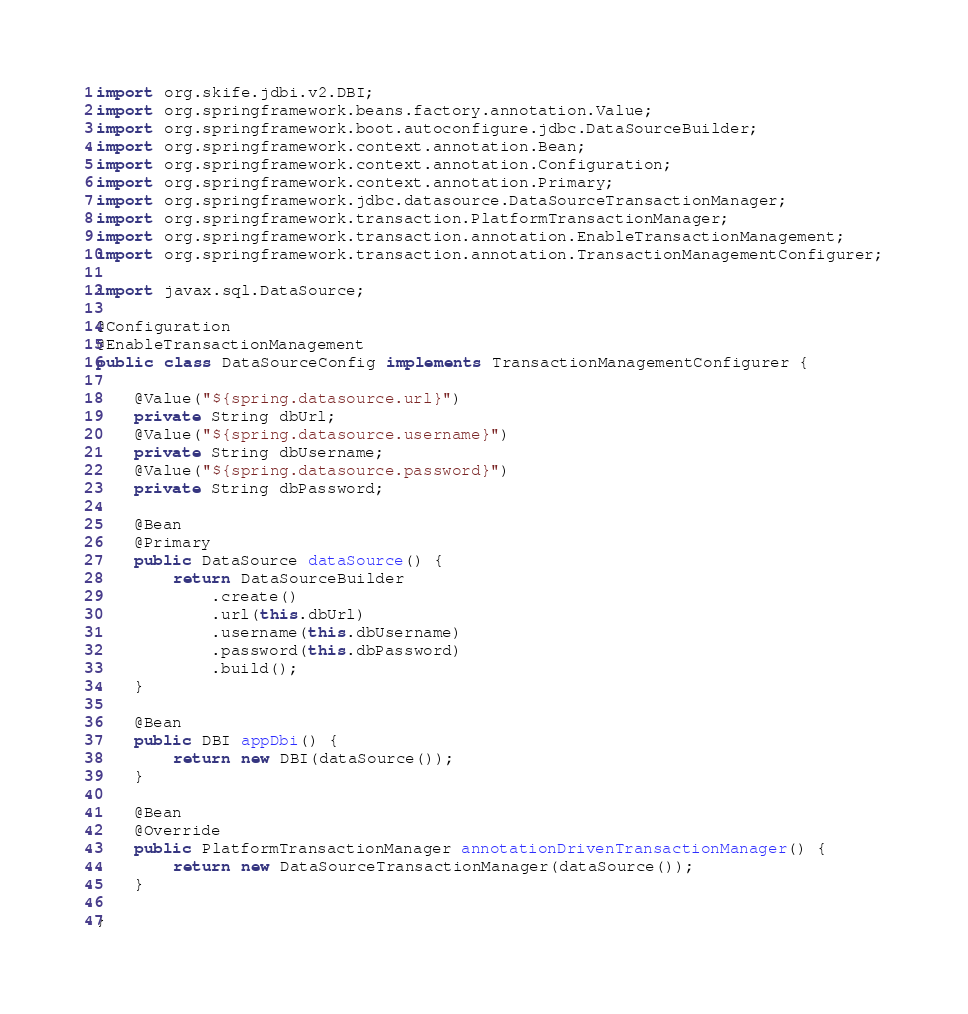<code> <loc_0><loc_0><loc_500><loc_500><_Java_>
import org.skife.jdbi.v2.DBI;
import org.springframework.beans.factory.annotation.Value;
import org.springframework.boot.autoconfigure.jdbc.DataSourceBuilder;
import org.springframework.context.annotation.Bean;
import org.springframework.context.annotation.Configuration;
import org.springframework.context.annotation.Primary;
import org.springframework.jdbc.datasource.DataSourceTransactionManager;
import org.springframework.transaction.PlatformTransactionManager;
import org.springframework.transaction.annotation.EnableTransactionManagement;
import org.springframework.transaction.annotation.TransactionManagementConfigurer;

import javax.sql.DataSource;

@Configuration
@EnableTransactionManagement
public class DataSourceConfig implements TransactionManagementConfigurer {

    @Value("${spring.datasource.url}")
    private String dbUrl;
    @Value("${spring.datasource.username}")
    private String dbUsername;
    @Value("${spring.datasource.password}")
    private String dbPassword;

    @Bean
    @Primary
    public DataSource dataSource() {
        return DataSourceBuilder
            .create()
            .url(this.dbUrl)
            .username(this.dbUsername)
            .password(this.dbPassword)
            .build();
    }

    @Bean
    public DBI appDbi() {
        return new DBI(dataSource());
    }

    @Bean
    @Override
    public PlatformTransactionManager annotationDrivenTransactionManager() {
        return new DataSourceTransactionManager(dataSource());
    }

}
</code> 